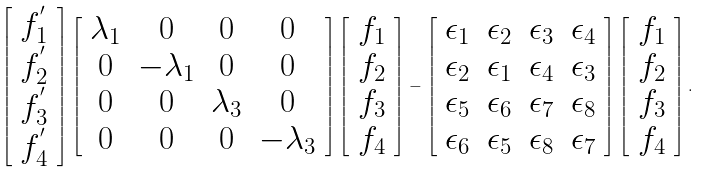Convert formula to latex. <formula><loc_0><loc_0><loc_500><loc_500>\left [ \begin{array} { c } f _ { 1 } ^ { ^ { \prime } } \\ f _ { 2 } ^ { ^ { \prime } } \\ f _ { 3 } ^ { ^ { \prime } } \\ f _ { 4 } ^ { ^ { \prime } } \end{array} \right ] \left [ \begin{array} { c c c c } \lambda _ { 1 } & 0 & 0 & 0 \\ 0 & - \lambda _ { 1 } & 0 & 0 \\ 0 & 0 & \lambda _ { 3 } & 0 \\ 0 & 0 & 0 & - \lambda _ { 3 } \end{array} \right ] \left [ \begin{array} { c } f _ { 1 } \\ f _ { 2 } \\ f _ { 3 } \\ f _ { 4 } \end{array} \right ] - \left [ \begin{array} { c c c c } \epsilon _ { 1 } & \epsilon _ { 2 } & \epsilon _ { 3 } & \epsilon _ { 4 } \\ \epsilon _ { 2 } & \epsilon _ { 1 } & \epsilon _ { 4 } & \epsilon _ { 3 } \\ \epsilon _ { 5 } & \epsilon _ { 6 } & \epsilon _ { 7 } & \epsilon _ { 8 } \\ \epsilon _ { 6 } & \epsilon _ { 5 } & \epsilon _ { 8 } & \epsilon _ { 7 } \\ \end{array} \right ] \left [ \begin{array} { c } f _ { 1 } \\ f _ { 2 } \\ f _ { 3 } \\ f _ { 4 } \end{array} \right ] .</formula> 